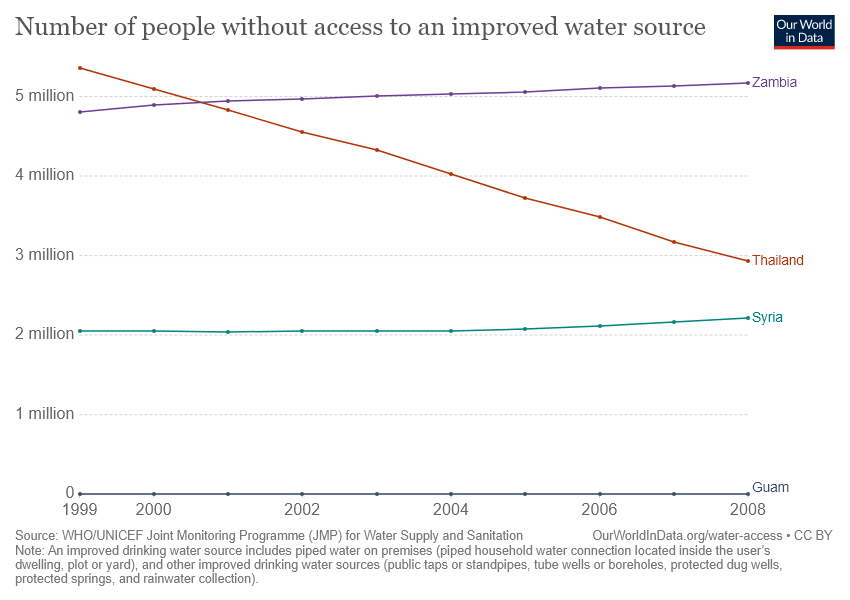Mention a couple of crucial points in this snapshot. In 2008, the least number of people without access to an improved drinking water source was recorded in Thailand. The line representing Zambia and Thailand crossed each other at one point. 